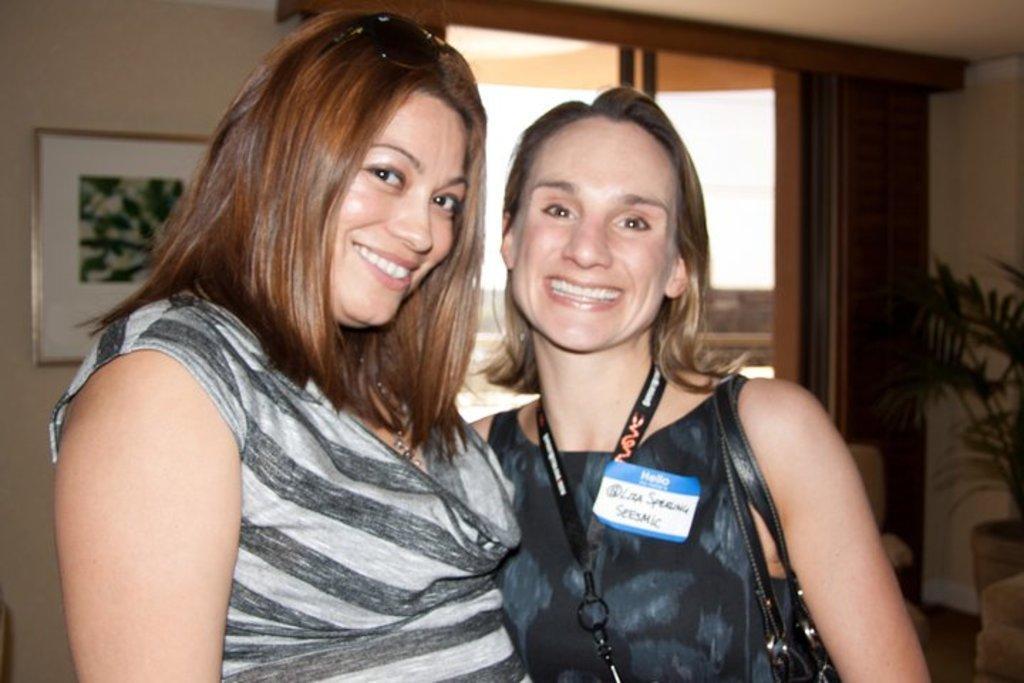How would you summarize this image in a sentence or two? In this image we can see two women wearing dress standing. One woman is carrying a bag. In the background, we can see a photo frame on the wall, a plant and a window. 